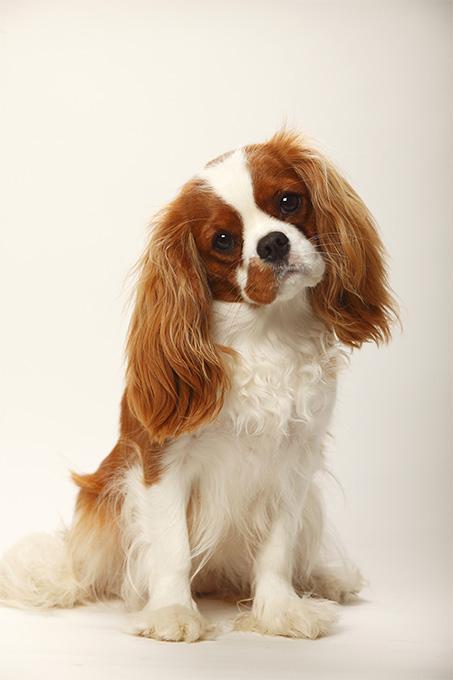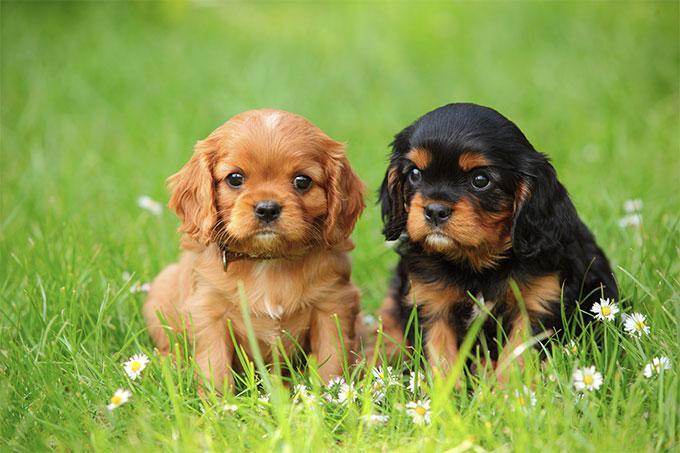The first image is the image on the left, the second image is the image on the right. Evaluate the accuracy of this statement regarding the images: "An image features a cluster of only brown and white spaniel dogs.". Is it true? Answer yes or no. No. The first image is the image on the left, the second image is the image on the right. For the images displayed, is the sentence "One or more dogs are posed in front of pink flowers." factually correct? Answer yes or no. No. 